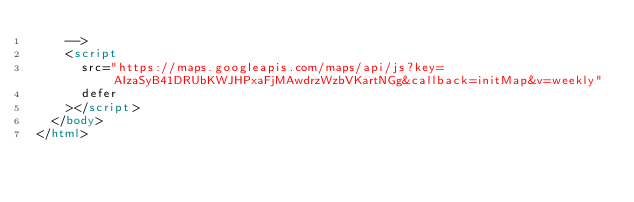<code> <loc_0><loc_0><loc_500><loc_500><_HTML_>    -->
    <script
      src="https://maps.googleapis.com/maps/api/js?key=AIzaSyB41DRUbKWJHPxaFjMAwdrzWzbVKartNGg&callback=initMap&v=weekly"
      defer
    ></script>
  </body>
</html>
</code> 